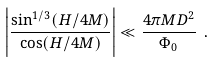Convert formula to latex. <formula><loc_0><loc_0><loc_500><loc_500>\left | \frac { \sin ^ { 1 / 3 } ( H / 4 M ) } { \cos ( H / 4 M ) } \right | \ll \frac { 4 \pi M D ^ { 2 } } { \Phi _ { 0 } } \ .</formula> 